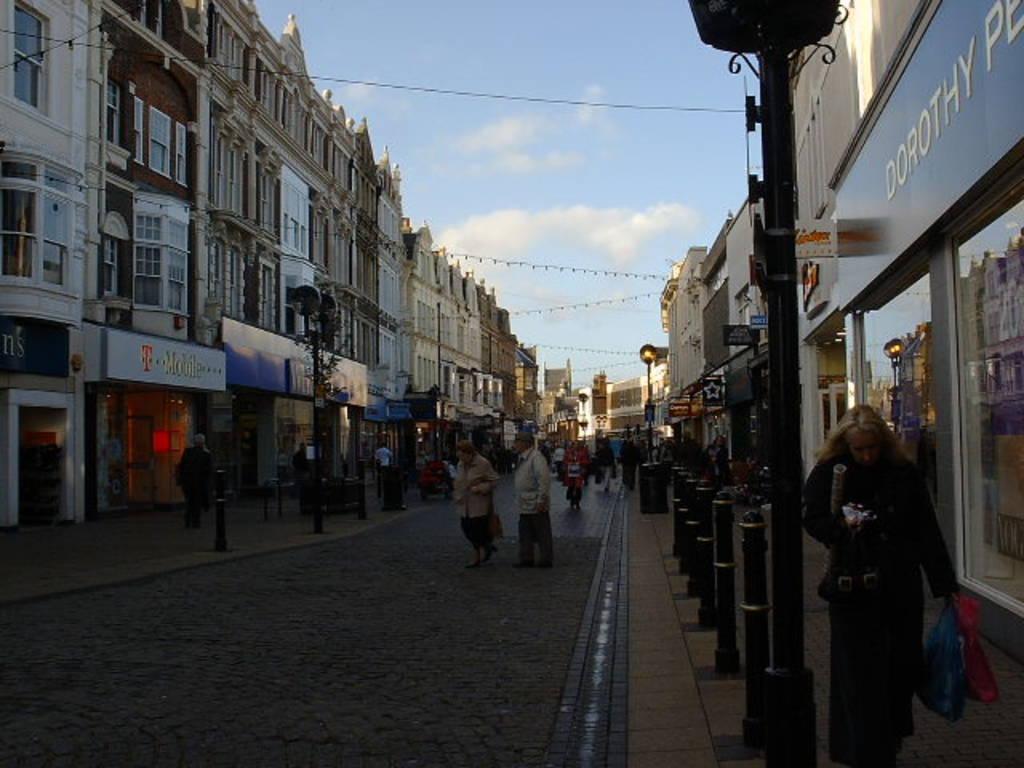Can you describe this image briefly? In this image It looks like a street, few people are walking, on the right side a woman is walking on the foot path. There are glass walls to this building and there are buildings on either side of this street, at the top it is the sky. 